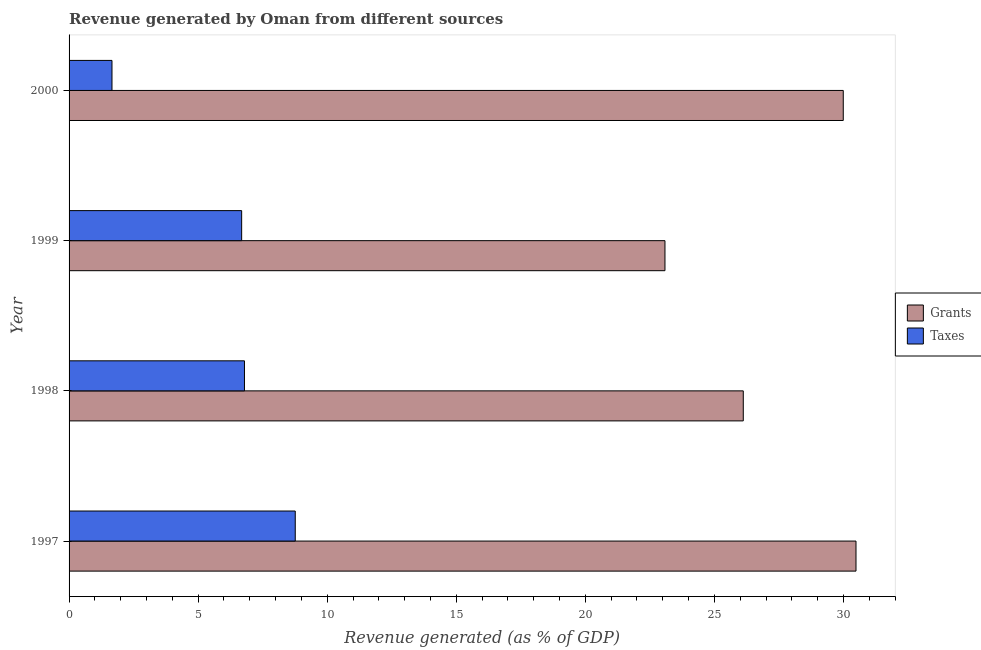How many groups of bars are there?
Provide a succinct answer. 4. In how many cases, is the number of bars for a given year not equal to the number of legend labels?
Your response must be concise. 0. What is the revenue generated by grants in 1997?
Your answer should be compact. 30.49. Across all years, what is the maximum revenue generated by grants?
Give a very brief answer. 30.49. Across all years, what is the minimum revenue generated by grants?
Give a very brief answer. 23.09. In which year was the revenue generated by taxes maximum?
Your answer should be very brief. 1997. In which year was the revenue generated by grants minimum?
Provide a short and direct response. 1999. What is the total revenue generated by taxes in the graph?
Keep it short and to the point. 23.91. What is the difference between the revenue generated by taxes in 1997 and that in 1999?
Make the answer very short. 2.08. What is the difference between the revenue generated by taxes in 1999 and the revenue generated by grants in 1997?
Keep it short and to the point. -23.8. What is the average revenue generated by taxes per year?
Provide a succinct answer. 5.98. In the year 1999, what is the difference between the revenue generated by taxes and revenue generated by grants?
Give a very brief answer. -16.4. In how many years, is the revenue generated by grants greater than 2 %?
Make the answer very short. 4. What is the ratio of the revenue generated by taxes in 1997 to that in 2000?
Make the answer very short. 5.27. What is the difference between the highest and the second highest revenue generated by taxes?
Offer a terse response. 1.97. What is the difference between the highest and the lowest revenue generated by taxes?
Make the answer very short. 7.1. In how many years, is the revenue generated by taxes greater than the average revenue generated by taxes taken over all years?
Your answer should be compact. 3. Is the sum of the revenue generated by taxes in 1997 and 2000 greater than the maximum revenue generated by grants across all years?
Give a very brief answer. No. What does the 2nd bar from the top in 1999 represents?
Offer a terse response. Grants. What does the 2nd bar from the bottom in 1999 represents?
Offer a very short reply. Taxes. How many years are there in the graph?
Your answer should be compact. 4. What is the difference between two consecutive major ticks on the X-axis?
Ensure brevity in your answer.  5. Does the graph contain grids?
Provide a succinct answer. No. How many legend labels are there?
Your answer should be very brief. 2. What is the title of the graph?
Make the answer very short. Revenue generated by Oman from different sources. Does "IMF concessional" appear as one of the legend labels in the graph?
Offer a very short reply. No. What is the label or title of the X-axis?
Keep it short and to the point. Revenue generated (as % of GDP). What is the label or title of the Y-axis?
Offer a terse response. Year. What is the Revenue generated (as % of GDP) in Grants in 1997?
Offer a very short reply. 30.49. What is the Revenue generated (as % of GDP) of Taxes in 1997?
Your answer should be compact. 8.76. What is the Revenue generated (as % of GDP) of Grants in 1998?
Make the answer very short. 26.12. What is the Revenue generated (as % of GDP) of Taxes in 1998?
Give a very brief answer. 6.79. What is the Revenue generated (as % of GDP) of Grants in 1999?
Offer a very short reply. 23.09. What is the Revenue generated (as % of GDP) of Taxes in 1999?
Give a very brief answer. 6.69. What is the Revenue generated (as % of GDP) in Grants in 2000?
Provide a short and direct response. 29.99. What is the Revenue generated (as % of GDP) of Taxes in 2000?
Your answer should be very brief. 1.66. Across all years, what is the maximum Revenue generated (as % of GDP) in Grants?
Your response must be concise. 30.49. Across all years, what is the maximum Revenue generated (as % of GDP) in Taxes?
Provide a succinct answer. 8.76. Across all years, what is the minimum Revenue generated (as % of GDP) in Grants?
Offer a terse response. 23.09. Across all years, what is the minimum Revenue generated (as % of GDP) in Taxes?
Ensure brevity in your answer.  1.66. What is the total Revenue generated (as % of GDP) of Grants in the graph?
Your answer should be compact. 109.69. What is the total Revenue generated (as % of GDP) in Taxes in the graph?
Keep it short and to the point. 23.91. What is the difference between the Revenue generated (as % of GDP) in Grants in 1997 and that in 1998?
Your answer should be compact. 4.37. What is the difference between the Revenue generated (as % of GDP) in Taxes in 1997 and that in 1998?
Make the answer very short. 1.97. What is the difference between the Revenue generated (as % of GDP) of Grants in 1997 and that in 1999?
Give a very brief answer. 7.4. What is the difference between the Revenue generated (as % of GDP) in Taxes in 1997 and that in 1999?
Provide a short and direct response. 2.08. What is the difference between the Revenue generated (as % of GDP) in Grants in 1997 and that in 2000?
Your answer should be very brief. 0.49. What is the difference between the Revenue generated (as % of GDP) of Taxes in 1997 and that in 2000?
Offer a very short reply. 7.1. What is the difference between the Revenue generated (as % of GDP) of Grants in 1998 and that in 1999?
Make the answer very short. 3.03. What is the difference between the Revenue generated (as % of GDP) in Taxes in 1998 and that in 1999?
Make the answer very short. 0.11. What is the difference between the Revenue generated (as % of GDP) of Grants in 1998 and that in 2000?
Ensure brevity in your answer.  -3.87. What is the difference between the Revenue generated (as % of GDP) of Taxes in 1998 and that in 2000?
Your answer should be very brief. 5.13. What is the difference between the Revenue generated (as % of GDP) in Grants in 1999 and that in 2000?
Provide a succinct answer. -6.91. What is the difference between the Revenue generated (as % of GDP) in Taxes in 1999 and that in 2000?
Keep it short and to the point. 5.02. What is the difference between the Revenue generated (as % of GDP) in Grants in 1997 and the Revenue generated (as % of GDP) in Taxes in 1998?
Your answer should be very brief. 23.69. What is the difference between the Revenue generated (as % of GDP) of Grants in 1997 and the Revenue generated (as % of GDP) of Taxes in 1999?
Make the answer very short. 23.8. What is the difference between the Revenue generated (as % of GDP) of Grants in 1997 and the Revenue generated (as % of GDP) of Taxes in 2000?
Keep it short and to the point. 28.82. What is the difference between the Revenue generated (as % of GDP) of Grants in 1998 and the Revenue generated (as % of GDP) of Taxes in 1999?
Your answer should be compact. 19.43. What is the difference between the Revenue generated (as % of GDP) in Grants in 1998 and the Revenue generated (as % of GDP) in Taxes in 2000?
Offer a very short reply. 24.46. What is the difference between the Revenue generated (as % of GDP) in Grants in 1999 and the Revenue generated (as % of GDP) in Taxes in 2000?
Your answer should be very brief. 21.42. What is the average Revenue generated (as % of GDP) of Grants per year?
Your answer should be very brief. 27.42. What is the average Revenue generated (as % of GDP) of Taxes per year?
Offer a very short reply. 5.98. In the year 1997, what is the difference between the Revenue generated (as % of GDP) in Grants and Revenue generated (as % of GDP) in Taxes?
Give a very brief answer. 21.72. In the year 1998, what is the difference between the Revenue generated (as % of GDP) of Grants and Revenue generated (as % of GDP) of Taxes?
Offer a very short reply. 19.32. In the year 1999, what is the difference between the Revenue generated (as % of GDP) in Grants and Revenue generated (as % of GDP) in Taxes?
Give a very brief answer. 16.4. In the year 2000, what is the difference between the Revenue generated (as % of GDP) of Grants and Revenue generated (as % of GDP) of Taxes?
Offer a terse response. 28.33. What is the ratio of the Revenue generated (as % of GDP) in Grants in 1997 to that in 1998?
Your response must be concise. 1.17. What is the ratio of the Revenue generated (as % of GDP) in Taxes in 1997 to that in 1998?
Provide a short and direct response. 1.29. What is the ratio of the Revenue generated (as % of GDP) of Grants in 1997 to that in 1999?
Provide a short and direct response. 1.32. What is the ratio of the Revenue generated (as % of GDP) in Taxes in 1997 to that in 1999?
Your answer should be very brief. 1.31. What is the ratio of the Revenue generated (as % of GDP) of Grants in 1997 to that in 2000?
Offer a terse response. 1.02. What is the ratio of the Revenue generated (as % of GDP) of Taxes in 1997 to that in 2000?
Offer a very short reply. 5.27. What is the ratio of the Revenue generated (as % of GDP) of Grants in 1998 to that in 1999?
Your response must be concise. 1.13. What is the ratio of the Revenue generated (as % of GDP) in Taxes in 1998 to that in 1999?
Ensure brevity in your answer.  1.02. What is the ratio of the Revenue generated (as % of GDP) in Grants in 1998 to that in 2000?
Ensure brevity in your answer.  0.87. What is the ratio of the Revenue generated (as % of GDP) in Taxes in 1998 to that in 2000?
Offer a very short reply. 4.09. What is the ratio of the Revenue generated (as % of GDP) of Grants in 1999 to that in 2000?
Give a very brief answer. 0.77. What is the ratio of the Revenue generated (as % of GDP) of Taxes in 1999 to that in 2000?
Make the answer very short. 4.02. What is the difference between the highest and the second highest Revenue generated (as % of GDP) of Grants?
Offer a terse response. 0.49. What is the difference between the highest and the second highest Revenue generated (as % of GDP) in Taxes?
Offer a terse response. 1.97. What is the difference between the highest and the lowest Revenue generated (as % of GDP) of Grants?
Make the answer very short. 7.4. What is the difference between the highest and the lowest Revenue generated (as % of GDP) of Taxes?
Ensure brevity in your answer.  7.1. 